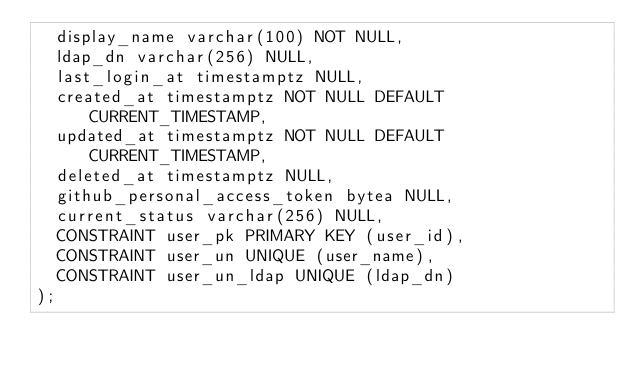<code> <loc_0><loc_0><loc_500><loc_500><_SQL_>  display_name varchar(100) NOT NULL,
  ldap_dn varchar(256) NULL,
  last_login_at timestamptz NULL,
  created_at timestamptz NOT NULL DEFAULT CURRENT_TIMESTAMP,
  updated_at timestamptz NOT NULL DEFAULT CURRENT_TIMESTAMP,
  deleted_at timestamptz NULL,
  github_personal_access_token bytea NULL,
  current_status varchar(256) NULL,
  CONSTRAINT user_pk PRIMARY KEY (user_id),
  CONSTRAINT user_un UNIQUE (user_name),
  CONSTRAINT user_un_ldap UNIQUE (ldap_dn)
);
</code> 